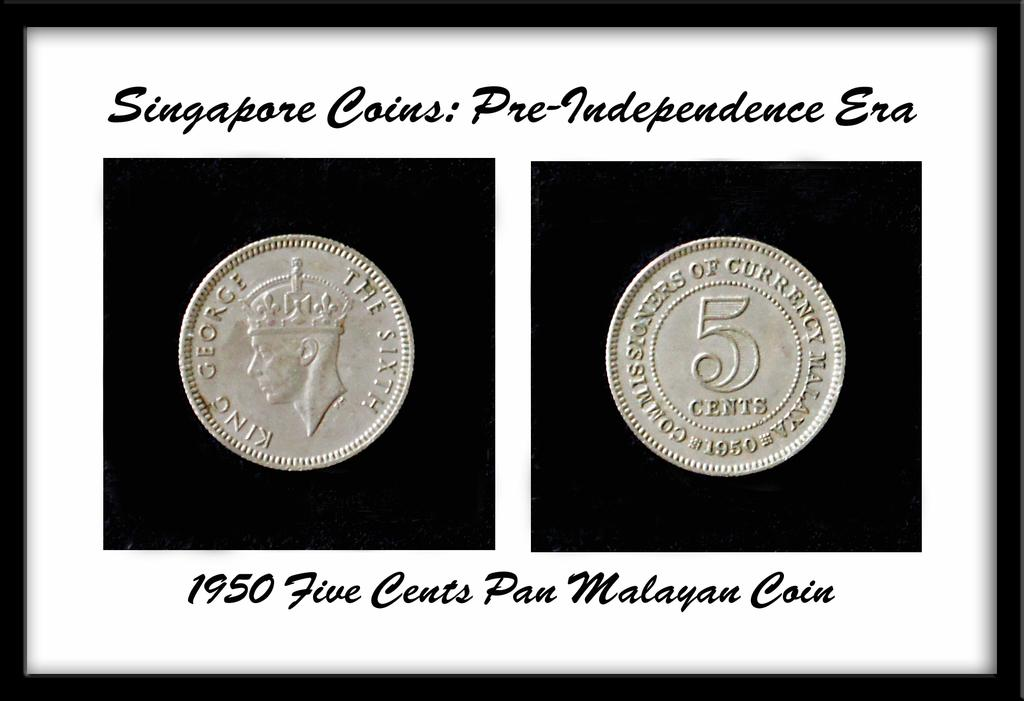<image>
Give a short and clear explanation of the subsequent image. Two framed coins are labeled as Pan Malayan from the year 1950. 